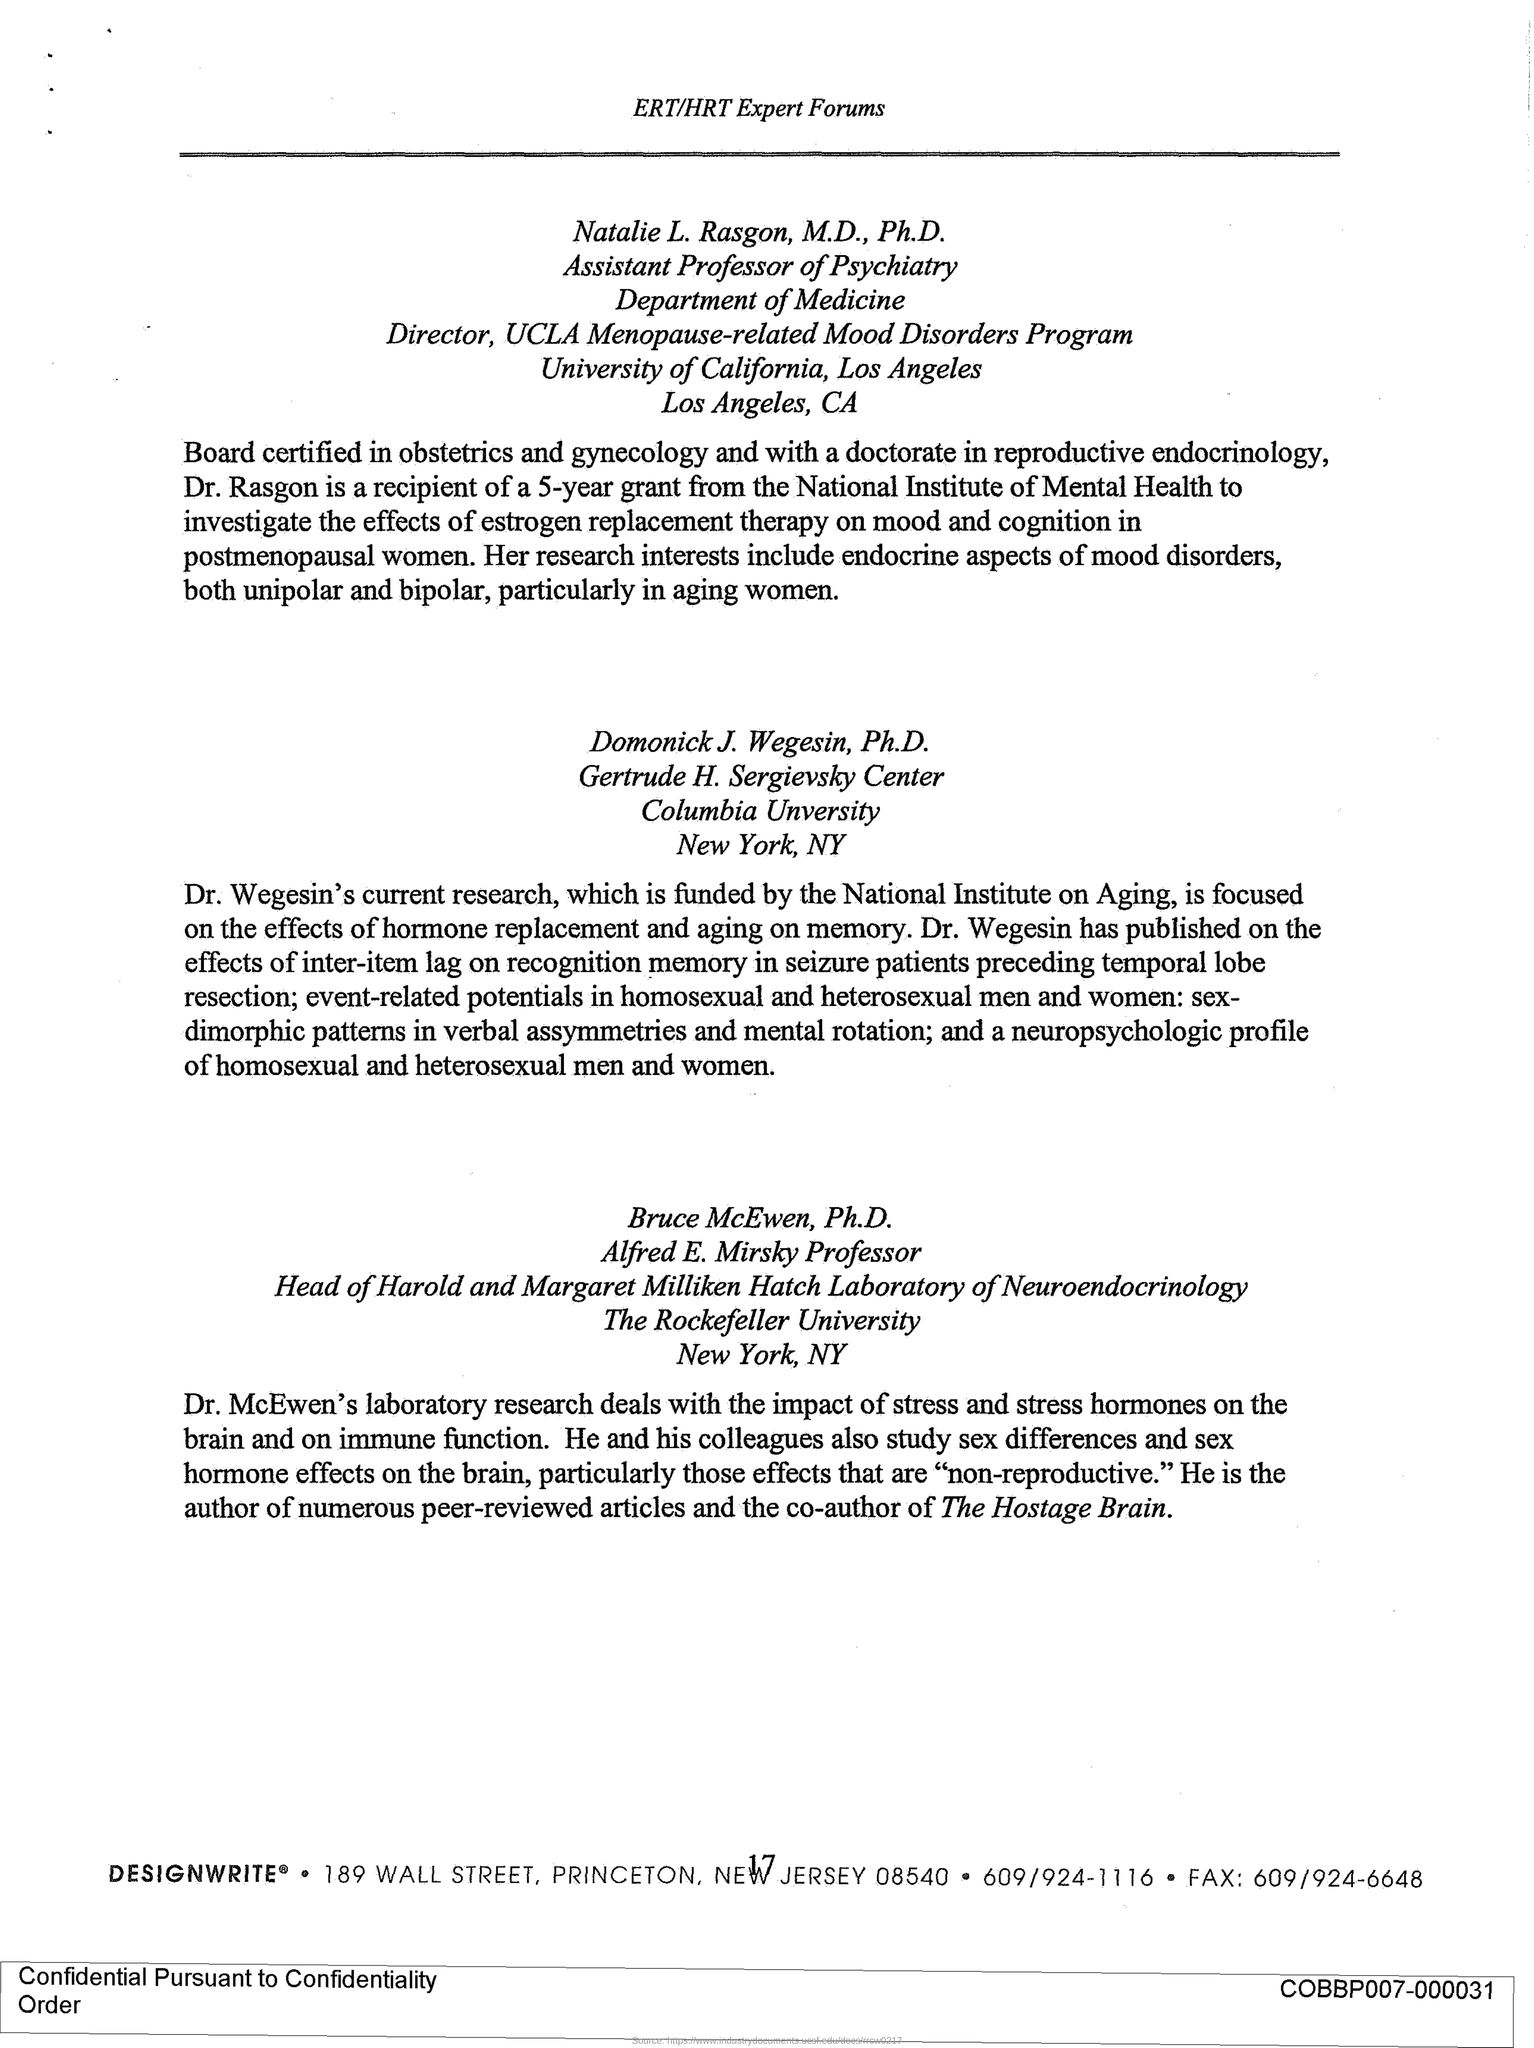Point out several critical features in this image. Natalie L. Rasagon works for the University of California. The city of Los Angeles is located within the University of California system. Dr. McEwen is the co-author of the article titled 'The Hostage Brain'. Dr. Wegesin is from Columbia University. Natalie L. Rasgon is an assistant professor of psychiatry, as her designation indicates. 